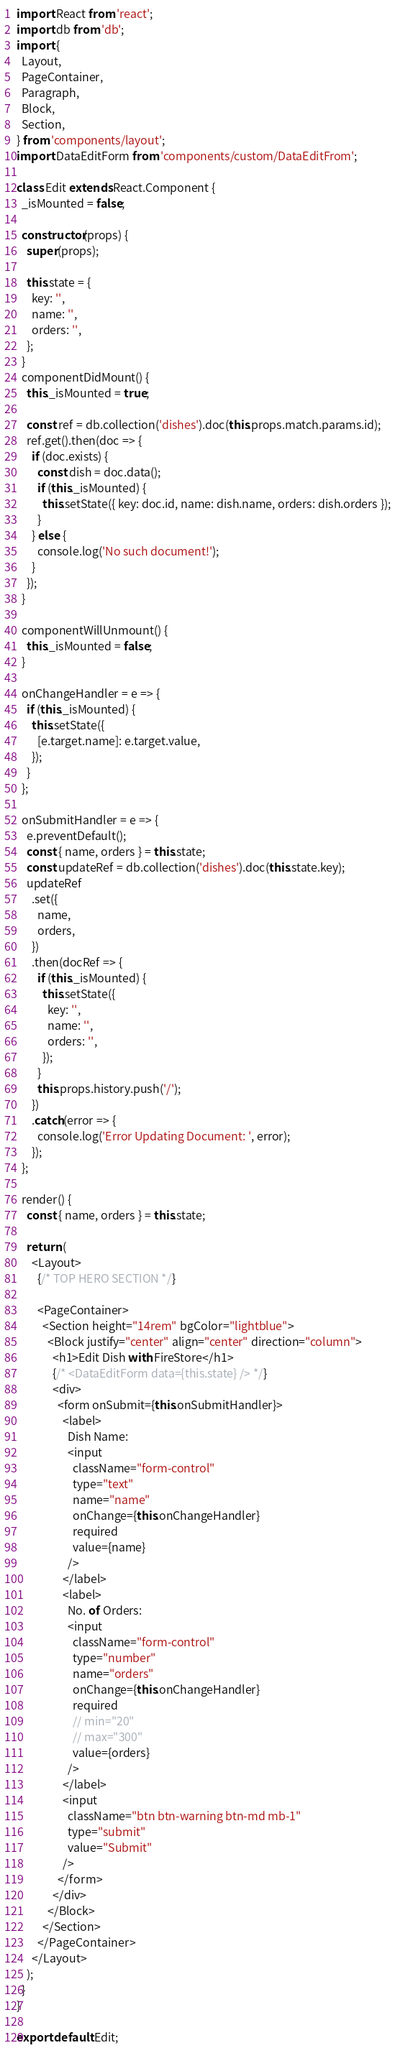Convert code to text. <code><loc_0><loc_0><loc_500><loc_500><_JavaScript_>import React from 'react';
import db from 'db';
import {
  Layout,
  PageContainer,
  Paragraph,
  Block,
  Section,
} from 'components/layout';
import DataEditForm from 'components/custom/DataEditFrom';

class Edit extends React.Component {
  _isMounted = false;

  constructor(props) {
    super(props);

    this.state = {
      key: '',
      name: '',
      orders: '',
    };
  }
  componentDidMount() {
    this._isMounted = true;

    const ref = db.collection('dishes').doc(this.props.match.params.id);
    ref.get().then(doc => {
      if (doc.exists) {
        const dish = doc.data();
        if (this._isMounted) {
          this.setState({ key: doc.id, name: dish.name, orders: dish.orders });
        }
      } else {
        console.log('No such document!');
      }
    });
  }

  componentWillUnmount() {
    this._isMounted = false;
  }

  onChangeHandler = e => {
    if (this._isMounted) {
      this.setState({
        [e.target.name]: e.target.value,
      });
    }
  };

  onSubmitHandler = e => {
    e.preventDefault();
    const { name, orders } = this.state;
    const updateRef = db.collection('dishes').doc(this.state.key);
    updateRef
      .set({
        name,
        orders,
      })
      .then(docRef => {
        if (this._isMounted) {
          this.setState({
            key: '',
            name: '',
            orders: '',
          });
        }
        this.props.history.push('/');
      })
      .catch(error => {
        console.log('Error Updating Document: ', error);
      });
  };

  render() {
    const { name, orders } = this.state;

    return (
      <Layout>
        {/* TOP HERO SECTION */}

        <PageContainer>
          <Section height="14rem" bgColor="lightblue">
            <Block justify="center" align="center" direction="column">
              <h1>Edit Dish with FireStore</h1>
              {/* <DataEditForm data={this.state} /> */}
              <div>
                <form onSubmit={this.onSubmitHandler}>
                  <label>
                    Dish Name:
                    <input
                      className="form-control"
                      type="text"
                      name="name"
                      onChange={this.onChangeHandler}
                      required
                      value={name}
                    />
                  </label>
                  <label>
                    No. of Orders:
                    <input
                      className="form-control"
                      type="number"
                      name="orders"
                      onChange={this.onChangeHandler}
                      required
                      // min="20"
                      // max="300"
                      value={orders}
                    />
                  </label>
                  <input
                    className="btn btn-warning btn-md mb-1"
                    type="submit"
                    value="Submit"
                  />
                </form>
              </div>
            </Block>
          </Section>
        </PageContainer>
      </Layout>
    );
  }
}

export default Edit;
</code> 